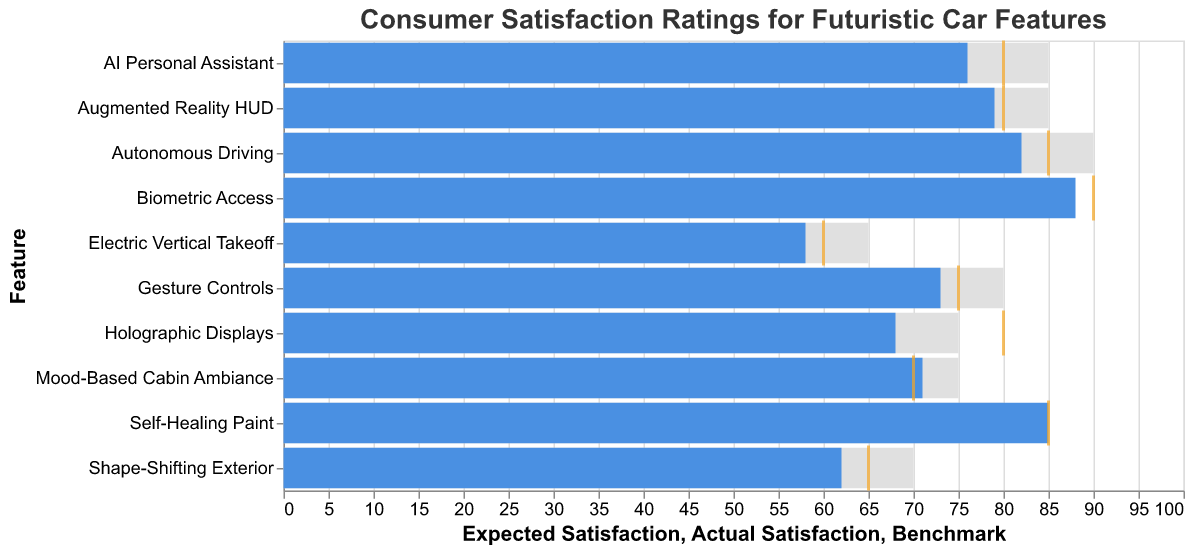What's the title of the chart? Look at the top of the chart where the title is usually located. The title summarizes the content of the chart.
Answer: Consumer Satisfaction Ratings for Futuristic Car Features What does the blue bar represent? The blue bar represents the actual consumer satisfaction ratings for each feature. This can be inferred from the data and the way the color is used in the legend/item.
Answer: Actual Satisfaction Which feature has the highest actual satisfaction rating? Check all blue bars to determine the highest one. The highest actual satisfaction rating is for "Biometric Access" at 88.
Answer: Biometric Access How many features exceeded the benchmark ratings? Compare the positions of the blue bars (Actual Satisfaction) to the orange ticks (Benchmark). Features to check: Autonomous Driving, Biometric Access, Self-Healing Paint, Mood-Based Cabin Ambiance.
Answer: 4 